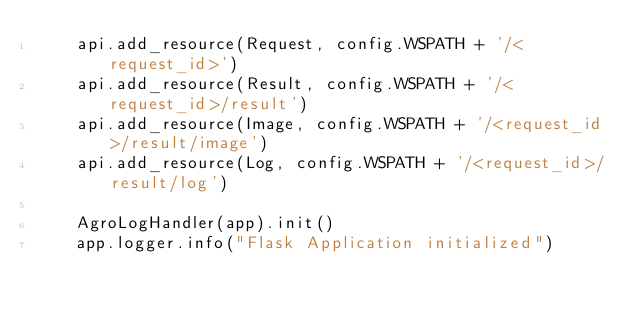<code> <loc_0><loc_0><loc_500><loc_500><_Python_>    api.add_resource(Request, config.WSPATH + '/<request_id>')
    api.add_resource(Result, config.WSPATH + '/<request_id>/result')
    api.add_resource(Image, config.WSPATH + '/<request_id>/result/image')
    api.add_resource(Log, config.WSPATH + '/<request_id>/result/log')

    AgroLogHandler(app).init()
    app.logger.info("Flask Application initialized")
</code> 